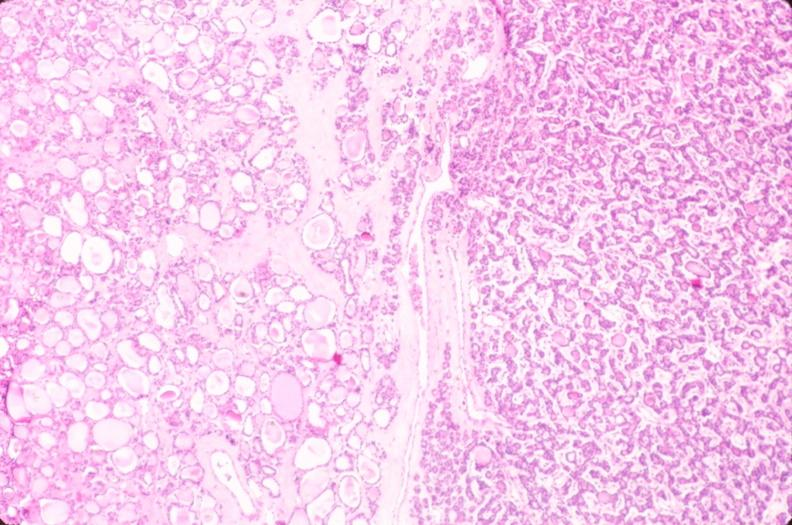what does this image show?
Answer the question using a single word or phrase. Thyroid 